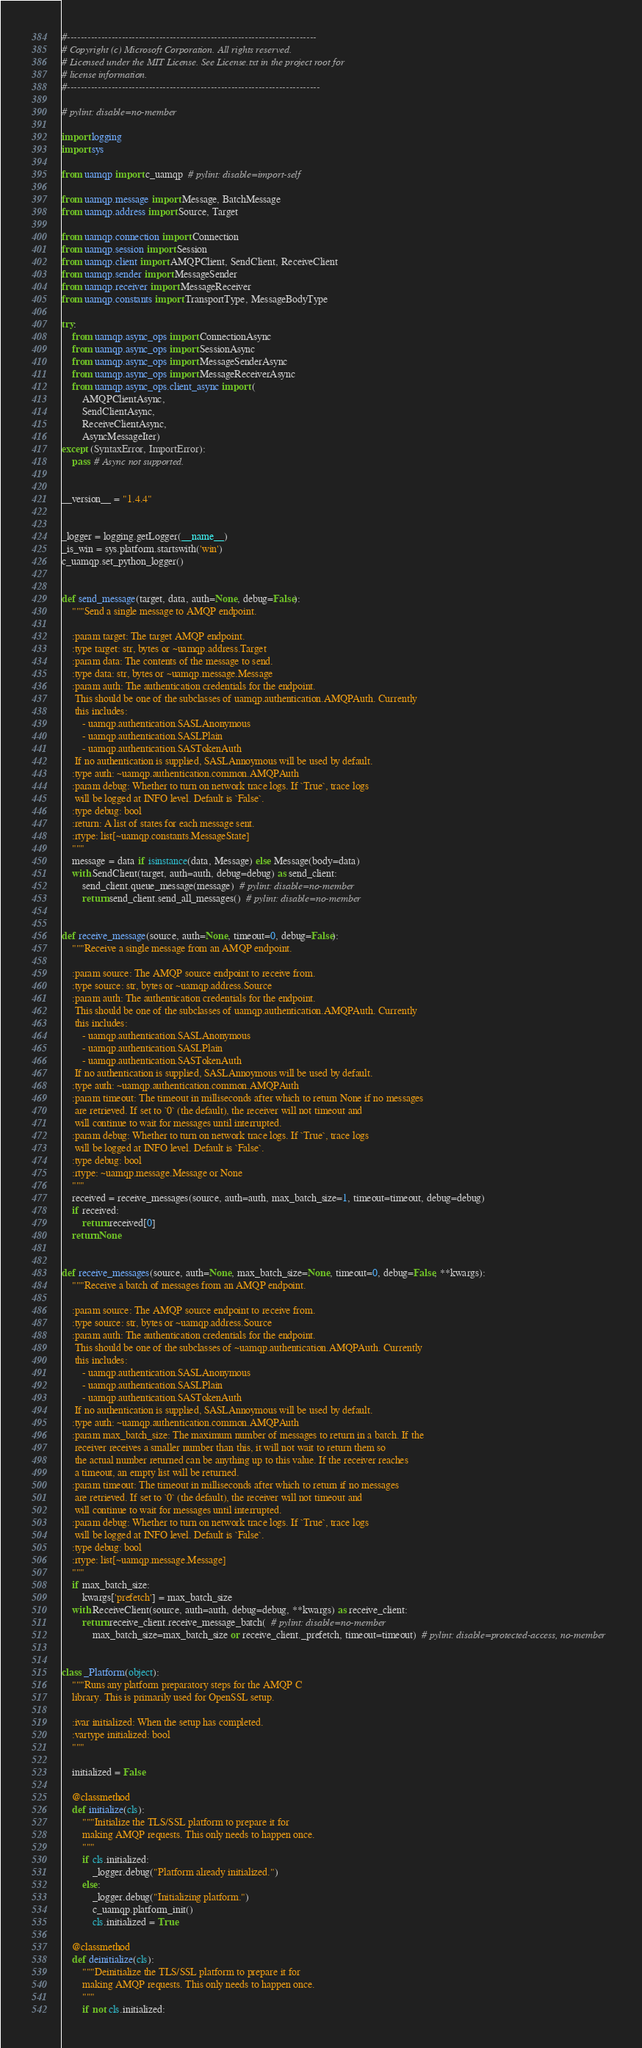Convert code to text. <code><loc_0><loc_0><loc_500><loc_500><_Python_>#-------------------------------------------------------------------------
# Copyright (c) Microsoft Corporation. All rights reserved.
# Licensed under the MIT License. See License.txt in the project root for
# license information.
#--------------------------------------------------------------------------

# pylint: disable=no-member

import logging
import sys

from uamqp import c_uamqp  # pylint: disable=import-self

from uamqp.message import Message, BatchMessage
from uamqp.address import Source, Target

from uamqp.connection import Connection
from uamqp.session import Session
from uamqp.client import AMQPClient, SendClient, ReceiveClient
from uamqp.sender import MessageSender
from uamqp.receiver import MessageReceiver
from uamqp.constants import TransportType, MessageBodyType

try:
    from uamqp.async_ops import ConnectionAsync
    from uamqp.async_ops import SessionAsync
    from uamqp.async_ops import MessageSenderAsync
    from uamqp.async_ops import MessageReceiverAsync
    from uamqp.async_ops.client_async import (
        AMQPClientAsync,
        SendClientAsync,
        ReceiveClientAsync,
        AsyncMessageIter)
except (SyntaxError, ImportError):
    pass  # Async not supported.


__version__ = "1.4.4"


_logger = logging.getLogger(__name__)
_is_win = sys.platform.startswith('win')
c_uamqp.set_python_logger()


def send_message(target, data, auth=None, debug=False):
    """Send a single message to AMQP endpoint.

    :param target: The target AMQP endpoint.
    :type target: str, bytes or ~uamqp.address.Target
    :param data: The contents of the message to send.
    :type data: str, bytes or ~uamqp.message.Message
    :param auth: The authentication credentials for the endpoint.
     This should be one of the subclasses of uamqp.authentication.AMQPAuth. Currently
     this includes:
        - uamqp.authentication.SASLAnonymous
        - uamqp.authentication.SASLPlain
        - uamqp.authentication.SASTokenAuth
     If no authentication is supplied, SASLAnnoymous will be used by default.
    :type auth: ~uamqp.authentication.common.AMQPAuth
    :param debug: Whether to turn on network trace logs. If `True`, trace logs
     will be logged at INFO level. Default is `False`.
    :type debug: bool
    :return: A list of states for each message sent.
    :rtype: list[~uamqp.constants.MessageState]
    """
    message = data if isinstance(data, Message) else Message(body=data)
    with SendClient(target, auth=auth, debug=debug) as send_client:
        send_client.queue_message(message)  # pylint: disable=no-member
        return send_client.send_all_messages()  # pylint: disable=no-member


def receive_message(source, auth=None, timeout=0, debug=False):
    """Receive a single message from an AMQP endpoint.

    :param source: The AMQP source endpoint to receive from.
    :type source: str, bytes or ~uamqp.address.Source
    :param auth: The authentication credentials for the endpoint.
     This should be one of the subclasses of uamqp.authentication.AMQPAuth. Currently
     this includes:
        - uamqp.authentication.SASLAnonymous
        - uamqp.authentication.SASLPlain
        - uamqp.authentication.SASTokenAuth
     If no authentication is supplied, SASLAnnoymous will be used by default.
    :type auth: ~uamqp.authentication.common.AMQPAuth
    :param timeout: The timeout in milliseconds after which to return None if no messages
     are retrieved. If set to `0` (the default), the receiver will not timeout and
     will continue to wait for messages until interrupted.
    :param debug: Whether to turn on network trace logs. If `True`, trace logs
     will be logged at INFO level. Default is `False`.
    :type debug: bool
    :rtype: ~uamqp.message.Message or None
    """
    received = receive_messages(source, auth=auth, max_batch_size=1, timeout=timeout, debug=debug)
    if received:
        return received[0]
    return None


def receive_messages(source, auth=None, max_batch_size=None, timeout=0, debug=False, **kwargs):
    """Receive a batch of messages from an AMQP endpoint.

    :param source: The AMQP source endpoint to receive from.
    :type source: str, bytes or ~uamqp.address.Source
    :param auth: The authentication credentials for the endpoint.
     This should be one of the subclasses of ~uamqp.authentication.AMQPAuth. Currently
     this includes:
        - uamqp.authentication.SASLAnonymous
        - uamqp.authentication.SASLPlain
        - uamqp.authentication.SASTokenAuth
     If no authentication is supplied, SASLAnnoymous will be used by default.
    :type auth: ~uamqp.authentication.common.AMQPAuth
    :param max_batch_size: The maximum number of messages to return in a batch. If the
     receiver receives a smaller number than this, it will not wait to return them so
     the actual number returned can be anything up to this value. If the receiver reaches
     a timeout, an empty list will be returned.
    :param timeout: The timeout in milliseconds after which to return if no messages
     are retrieved. If set to `0` (the default), the receiver will not timeout and
     will continue to wait for messages until interrupted.
    :param debug: Whether to turn on network trace logs. If `True`, trace logs
     will be logged at INFO level. Default is `False`.
    :type debug: bool
    :rtype: list[~uamqp.message.Message]
    """
    if max_batch_size:
        kwargs['prefetch'] = max_batch_size
    with ReceiveClient(source, auth=auth, debug=debug, **kwargs) as receive_client:
        return receive_client.receive_message_batch(  # pylint: disable=no-member
            max_batch_size=max_batch_size or receive_client._prefetch, timeout=timeout)  # pylint: disable=protected-access, no-member


class _Platform(object):
    """Runs any platform preparatory steps for the AMQP C
    library. This is primarily used for OpenSSL setup.

    :ivar initialized: When the setup has completed.
    :vartype initialized: bool
    """

    initialized = False

    @classmethod
    def initialize(cls):
        """Initialize the TLS/SSL platform to prepare it for
        making AMQP requests. This only needs to happen once.
        """
        if cls.initialized:
            _logger.debug("Platform already initialized.")
        else:
            _logger.debug("Initializing platform.")
            c_uamqp.platform_init()
            cls.initialized = True

    @classmethod
    def deinitialize(cls):
        """Deinitialize the TLS/SSL platform to prepare it for
        making AMQP requests. This only needs to happen once.
        """
        if not cls.initialized:</code> 